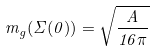<formula> <loc_0><loc_0><loc_500><loc_500>m _ { g } ( \Sigma ( 0 ) ) = \sqrt { \frac { A } { 1 6 \pi } }</formula> 